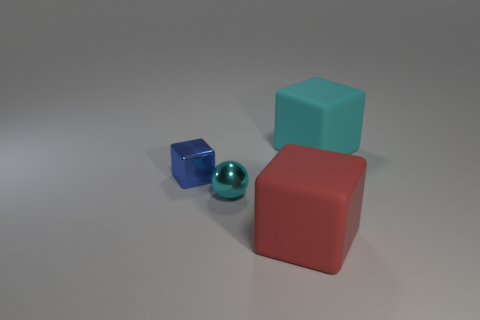There is a large cyan object that is the same shape as the blue metal thing; what material is it?
Make the answer very short. Rubber. What color is the metal ball?
Provide a succinct answer. Cyan. The rubber thing that is behind the matte block in front of the big cyan rubber block is what color?
Provide a short and direct response. Cyan. Is the color of the small cube the same as the big object behind the large red matte object?
Make the answer very short. No. What number of blue metal objects are in front of the tiny object behind the small sphere in front of the small blue object?
Your response must be concise. 0. Are there any small blue metal blocks behind the blue cube?
Make the answer very short. No. Is there any other thing that has the same color as the shiny cube?
Your answer should be very brief. No. How many cylinders are either blue metallic things or tiny cyan shiny objects?
Provide a succinct answer. 0. What number of objects are both on the right side of the sphere and behind the tiny cyan object?
Provide a succinct answer. 1. Are there an equal number of big rubber cubes behind the small metal sphere and tiny metallic objects to the left of the large cyan cube?
Your answer should be very brief. No. 